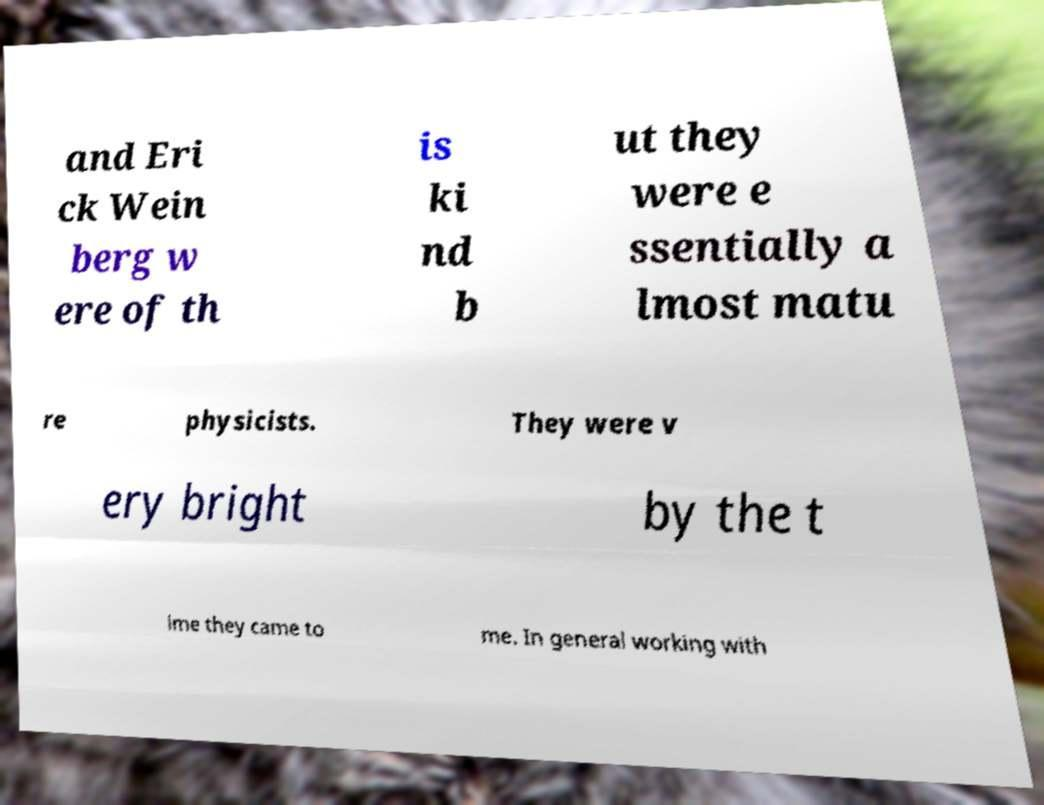Can you tell me more about the content or the topic discussed in the text on this image? The text in the image discusses individuals named 'Erick Weinberg' who were nearly mature physicists and described as very bright. It seems to address their intellectual capabilities and possibly their development or contributions in the field of physics. 